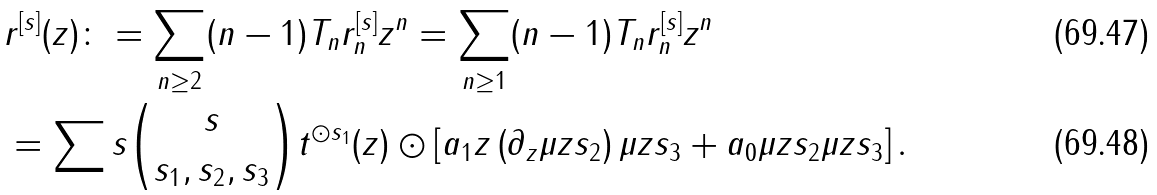<formula> <loc_0><loc_0><loc_500><loc_500>& r ^ { [ s ] } ( z ) \colon = \sum _ { n \geq 2 } ( n - 1 ) T _ { n } r _ { n } ^ { [ s ] } z ^ { n } = \sum _ { n \geq 1 } ( n - 1 ) T _ { n } r _ { n } ^ { [ s ] } z ^ { n } \\ & = \sum s \binom { s } { s _ { 1 } , s _ { 2 } , s _ { 3 } } t ^ { \odot s _ { 1 } } ( z ) \odot \left [ a _ { 1 } z \left ( \partial _ { z } \mu z { s _ { 2 } } \right ) \mu z { s _ { 3 } } + a _ { 0 } \mu z { s _ { 2 } } \mu z { s _ { 3 } } \right ] .</formula> 